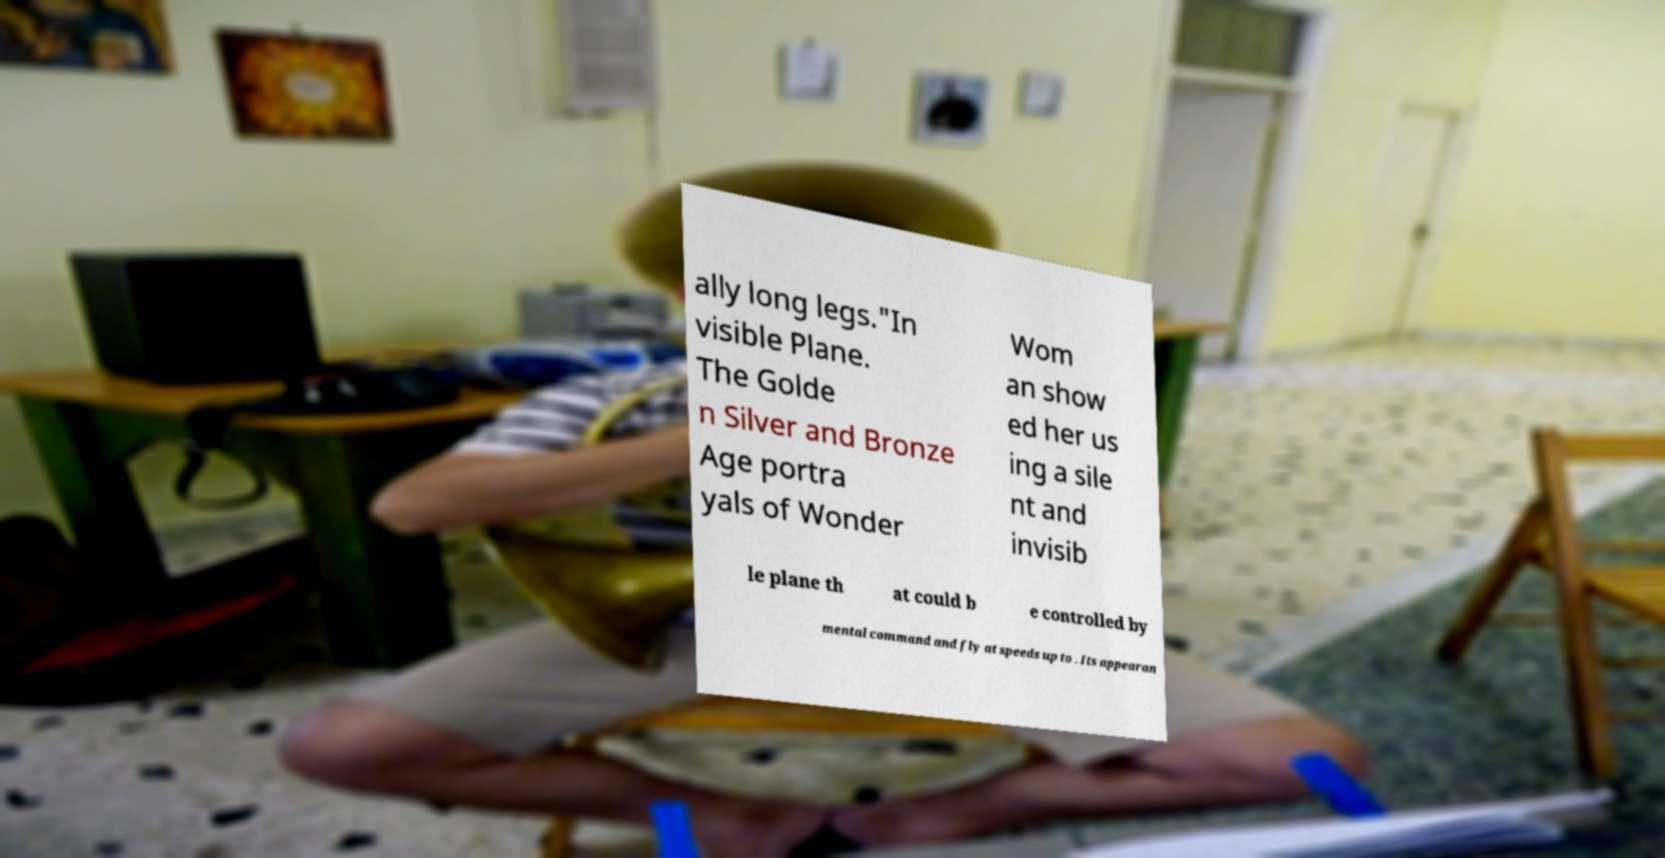Could you assist in decoding the text presented in this image and type it out clearly? ally long legs."In visible Plane. The Golde n Silver and Bronze Age portra yals of Wonder Wom an show ed her us ing a sile nt and invisib le plane th at could b e controlled by mental command and fly at speeds up to . Its appearan 